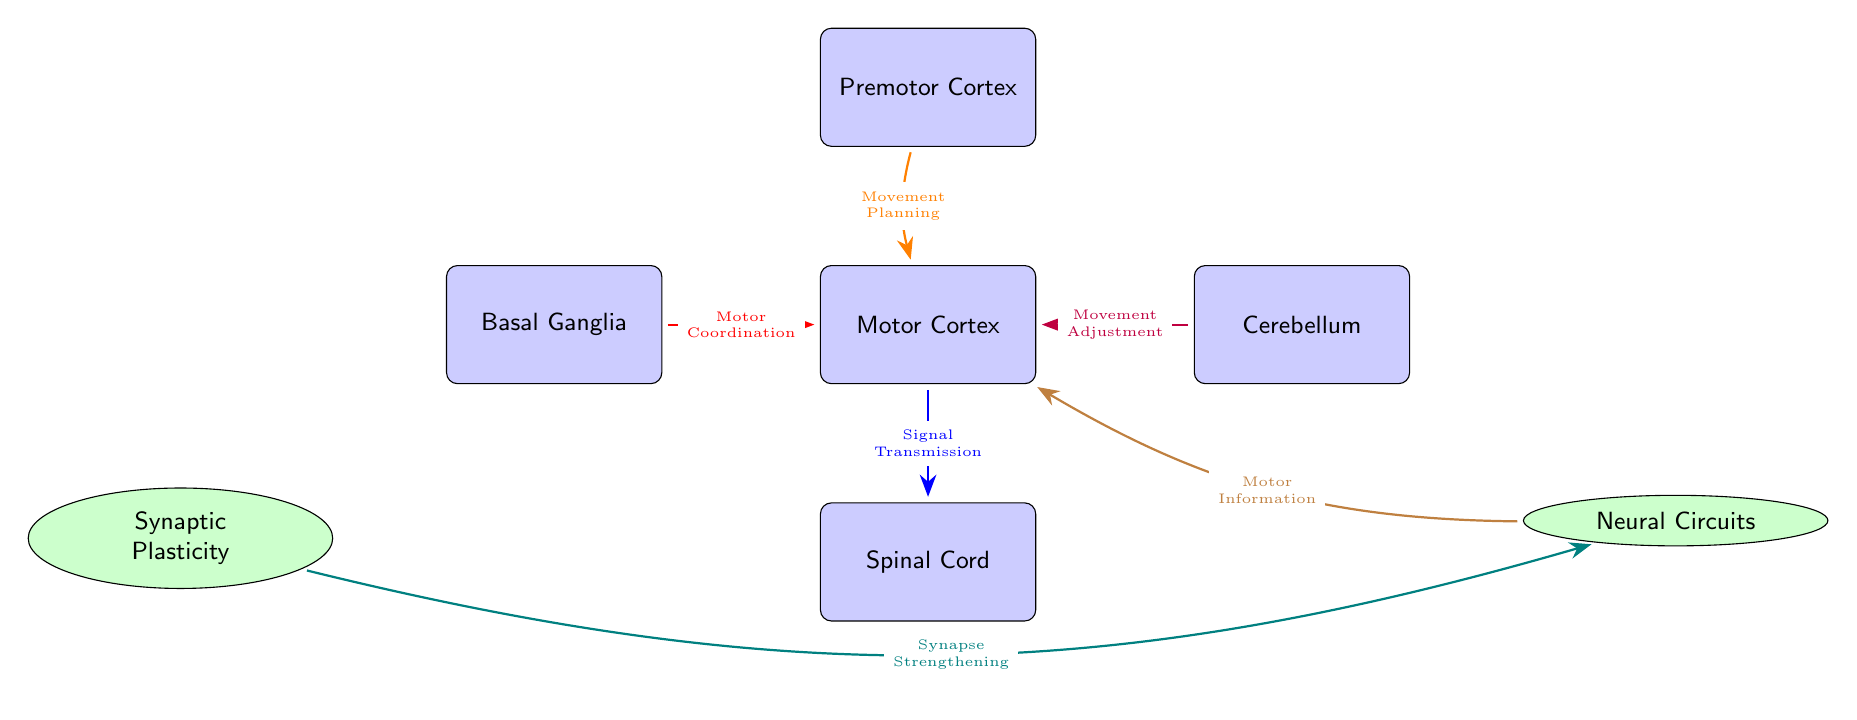What are the two types of neural components shown in the diagram? The diagram shows two types of components: the brain parts (Motor Cortex, Premotor Cortex, Basal Ganglia, Cerebellum, and Spinal Cord) and processes (Synaptic Plasticity and Neural Circuits).
Answer: Brain parts and processes How many brain parts are illustrated in the diagram? The diagram contains five brain parts: Motor Cortex, Premotor Cortex, Basal Ganglia, Cerebellum, and Spinal Cord.
Answer: Five What is the function of the Basal Ganglia as indicated in the diagram? According to the diagram, the Basal Ganglia is involved in Motor Coordination, which connects to the Motor Cortex.
Answer: Motor Coordination What is the relationship between Synaptic Plasticity and Neural Circuits as per the diagram? The diagram indicates that Synaptic Plasticity involves Synapse Strengthening, which impacts Neural Circuits leading to Motor Information transfer to the Motor Cortex.
Answer: Synapse Strengthening Identify the pathway that represents movement planning. The pathway from the Premotor Cortex to the Motor Cortex with an orange connection represents Movement Planning.
Answer: Movement Planning Which brain part interacts directly with the spinal cord? The Motor Cortex communicates directly with the Spinal Cord to facilitate Signal Transmission.
Answer: Motor Cortex What color connection represents movement adjustment in the diagram? The connection representing Movement Adjustment is colored purple, connecting the Cerebellum to the Motor Cortex.
Answer: Purple Which process strengthens synapses in neural pathways? The process indicated in the diagram that strengthens synapses is Synaptic Plasticity.
Answer: Synaptic Plasticity Explain the flow of information from Neural Circuits to the Motor Cortex. The diagram illustrates that information flows from Neural Circuits to the Motor Cortex through the process labeled as Motor Information. This involves the connection showing how neural circuits process and relay information to the motor cortex, indicating a clear direction of communication.
Answer: Motor Information 